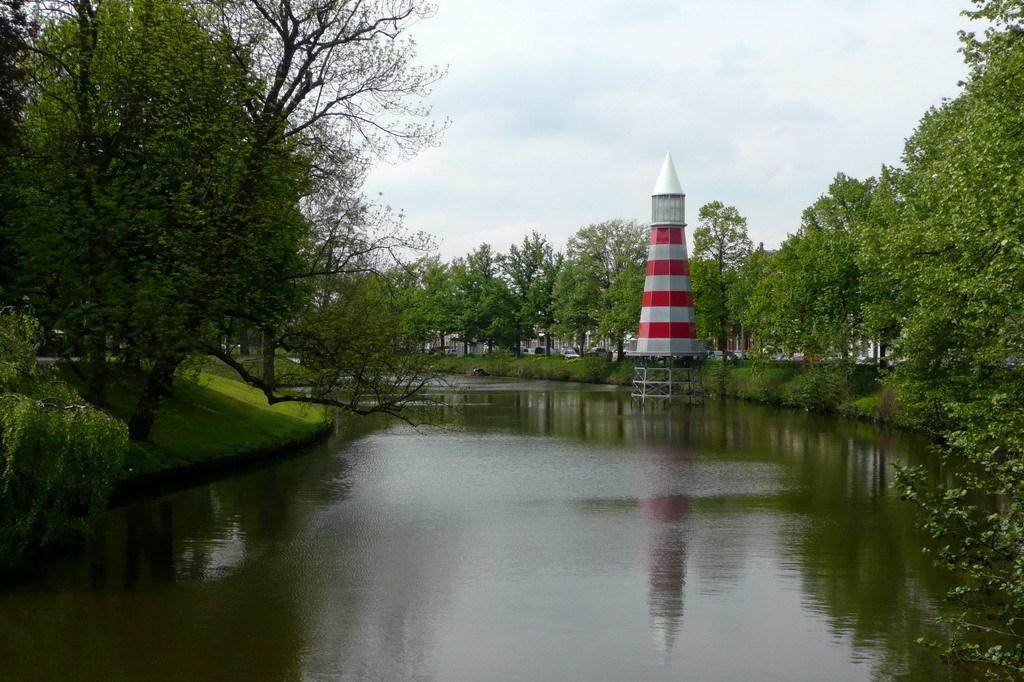What is the main feature of the landscape in the image? There is a water surface in the image. What type of vegetation is present around the water surface? There are trees and grass around the water surface. What type of structure can be seen on the right side of the image? There is a lighthouse on the right side of the image. How many beggars are present near the lighthouse in the image? There are no beggars present in the image. Who is the owner of the lighthouse in the image? The image does not provide information about the ownership of the lighthouse. 